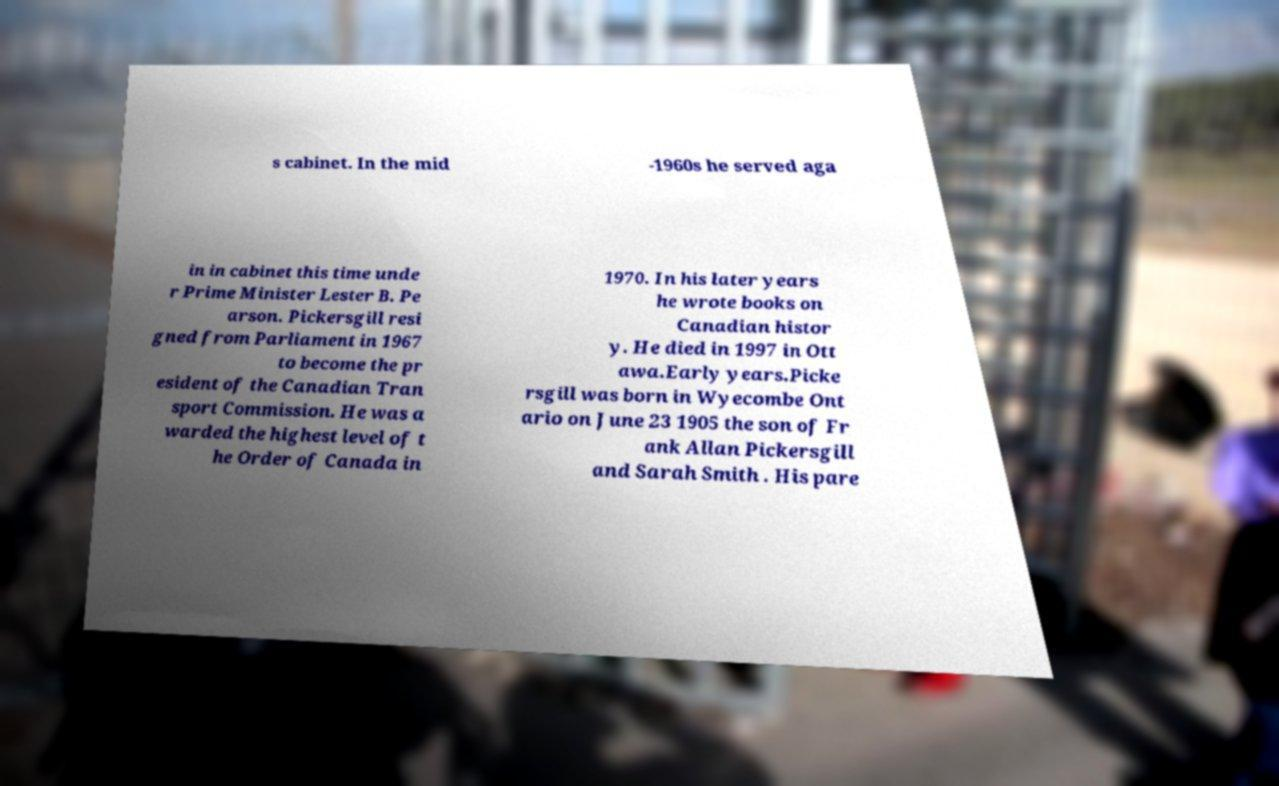Can you read and provide the text displayed in the image?This photo seems to have some interesting text. Can you extract and type it out for me? s cabinet. In the mid -1960s he served aga in in cabinet this time unde r Prime Minister Lester B. Pe arson. Pickersgill resi gned from Parliament in 1967 to become the pr esident of the Canadian Tran sport Commission. He was a warded the highest level of t he Order of Canada in 1970. In his later years he wrote books on Canadian histor y. He died in 1997 in Ott awa.Early years.Picke rsgill was born in Wyecombe Ont ario on June 23 1905 the son of Fr ank Allan Pickersgill and Sarah Smith . His pare 